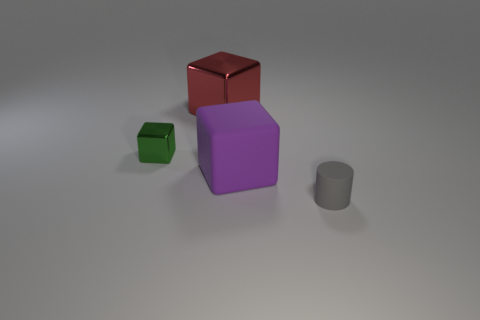How big is the matte object that is to the left of the tiny object that is in front of the purple cube?
Make the answer very short. Large. There is a tiny object that is the same shape as the large purple object; what is its color?
Give a very brief answer. Green. What number of cylinders are the same color as the big rubber cube?
Provide a short and direct response. 0. How big is the cylinder?
Your answer should be compact. Small. Does the green cube have the same size as the red block?
Give a very brief answer. No. What is the color of the thing that is behind the tiny rubber object and in front of the small cube?
Ensure brevity in your answer.  Purple. What number of other purple blocks have the same material as the small block?
Offer a very short reply. 0. What number of large gray shiny objects are there?
Provide a short and direct response. 0. There is a gray matte cylinder; is its size the same as the metal thing in front of the red metallic thing?
Provide a short and direct response. Yes. There is a large block that is behind the small thing that is on the left side of the gray rubber thing; what is its material?
Keep it short and to the point. Metal. 